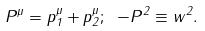<formula> <loc_0><loc_0><loc_500><loc_500>P ^ { \mu } = p _ { 1 } ^ { \mu } + p _ { 2 } ^ { \mu } ; \ - P ^ { 2 } \equiv w ^ { 2 } .</formula> 